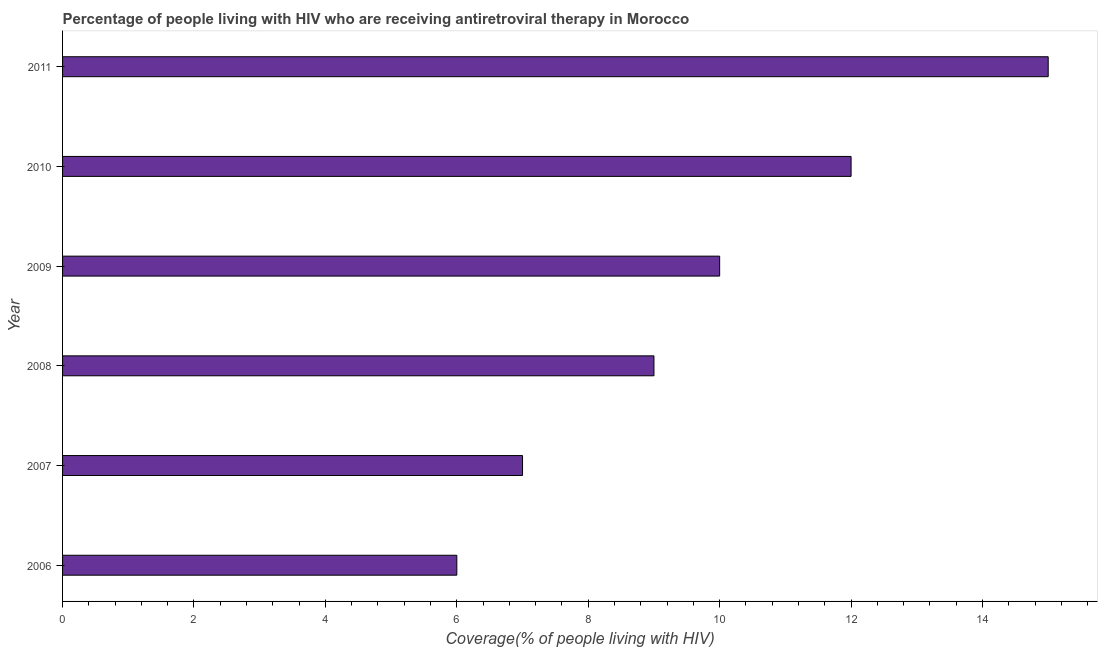What is the title of the graph?
Provide a short and direct response. Percentage of people living with HIV who are receiving antiretroviral therapy in Morocco. What is the label or title of the X-axis?
Offer a terse response. Coverage(% of people living with HIV). Across all years, what is the minimum antiretroviral therapy coverage?
Make the answer very short. 6. What is the difference between the antiretroviral therapy coverage in 2007 and 2009?
Your answer should be very brief. -3. In how many years, is the antiretroviral therapy coverage greater than 12 %?
Offer a very short reply. 1. What is the difference between the highest and the second highest antiretroviral therapy coverage?
Offer a terse response. 3. Is the sum of the antiretroviral therapy coverage in 2007 and 2009 greater than the maximum antiretroviral therapy coverage across all years?
Keep it short and to the point. Yes. What is the difference between the highest and the lowest antiretroviral therapy coverage?
Offer a very short reply. 9. In how many years, is the antiretroviral therapy coverage greater than the average antiretroviral therapy coverage taken over all years?
Your answer should be compact. 3. Are all the bars in the graph horizontal?
Your answer should be very brief. Yes. What is the difference between two consecutive major ticks on the X-axis?
Keep it short and to the point. 2. What is the Coverage(% of people living with HIV) in 2006?
Your answer should be compact. 6. What is the Coverage(% of people living with HIV) in 2010?
Your answer should be compact. 12. What is the Coverage(% of people living with HIV) in 2011?
Provide a succinct answer. 15. What is the difference between the Coverage(% of people living with HIV) in 2006 and 2007?
Keep it short and to the point. -1. What is the difference between the Coverage(% of people living with HIV) in 2006 and 2008?
Offer a very short reply. -3. What is the difference between the Coverage(% of people living with HIV) in 2006 and 2010?
Keep it short and to the point. -6. What is the difference between the Coverage(% of people living with HIV) in 2007 and 2008?
Offer a very short reply. -2. What is the difference between the Coverage(% of people living with HIV) in 2007 and 2009?
Ensure brevity in your answer.  -3. What is the difference between the Coverage(% of people living with HIV) in 2007 and 2010?
Make the answer very short. -5. What is the difference between the Coverage(% of people living with HIV) in 2008 and 2009?
Keep it short and to the point. -1. What is the difference between the Coverage(% of people living with HIV) in 2008 and 2010?
Provide a succinct answer. -3. What is the difference between the Coverage(% of people living with HIV) in 2010 and 2011?
Make the answer very short. -3. What is the ratio of the Coverage(% of people living with HIV) in 2006 to that in 2007?
Provide a succinct answer. 0.86. What is the ratio of the Coverage(% of people living with HIV) in 2006 to that in 2008?
Provide a succinct answer. 0.67. What is the ratio of the Coverage(% of people living with HIV) in 2006 to that in 2011?
Offer a very short reply. 0.4. What is the ratio of the Coverage(% of people living with HIV) in 2007 to that in 2008?
Your answer should be compact. 0.78. What is the ratio of the Coverage(% of people living with HIV) in 2007 to that in 2009?
Offer a terse response. 0.7. What is the ratio of the Coverage(% of people living with HIV) in 2007 to that in 2010?
Your answer should be compact. 0.58. What is the ratio of the Coverage(% of people living with HIV) in 2007 to that in 2011?
Offer a very short reply. 0.47. What is the ratio of the Coverage(% of people living with HIV) in 2008 to that in 2010?
Provide a succinct answer. 0.75. What is the ratio of the Coverage(% of people living with HIV) in 2009 to that in 2010?
Offer a very short reply. 0.83. What is the ratio of the Coverage(% of people living with HIV) in 2009 to that in 2011?
Keep it short and to the point. 0.67. 